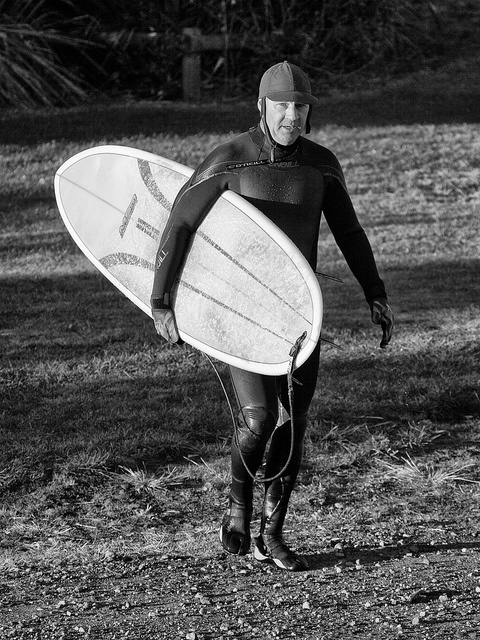Describe the objects in this image and their specific colors. I can see people in black, gray, darkgray, and lightgray tones and surfboard in black, lightgray, darkgray, and gray tones in this image. 